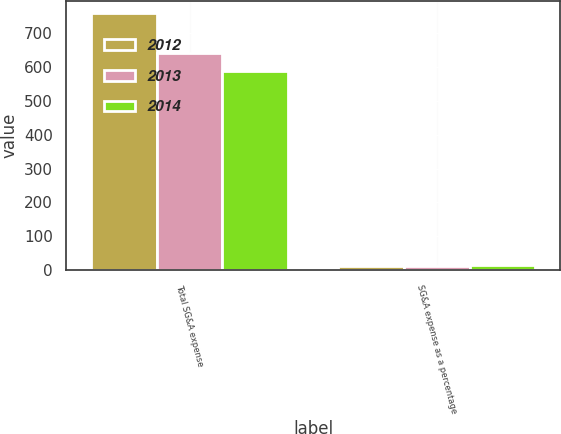Convert chart. <chart><loc_0><loc_0><loc_500><loc_500><stacked_bar_chart><ecel><fcel>Total SG&A expense<fcel>SG&A expense as a percentage<nl><fcel>2012<fcel>758<fcel>13.3<nl><fcel>2013<fcel>642<fcel>13<nl><fcel>2014<fcel>588<fcel>14.3<nl></chart> 